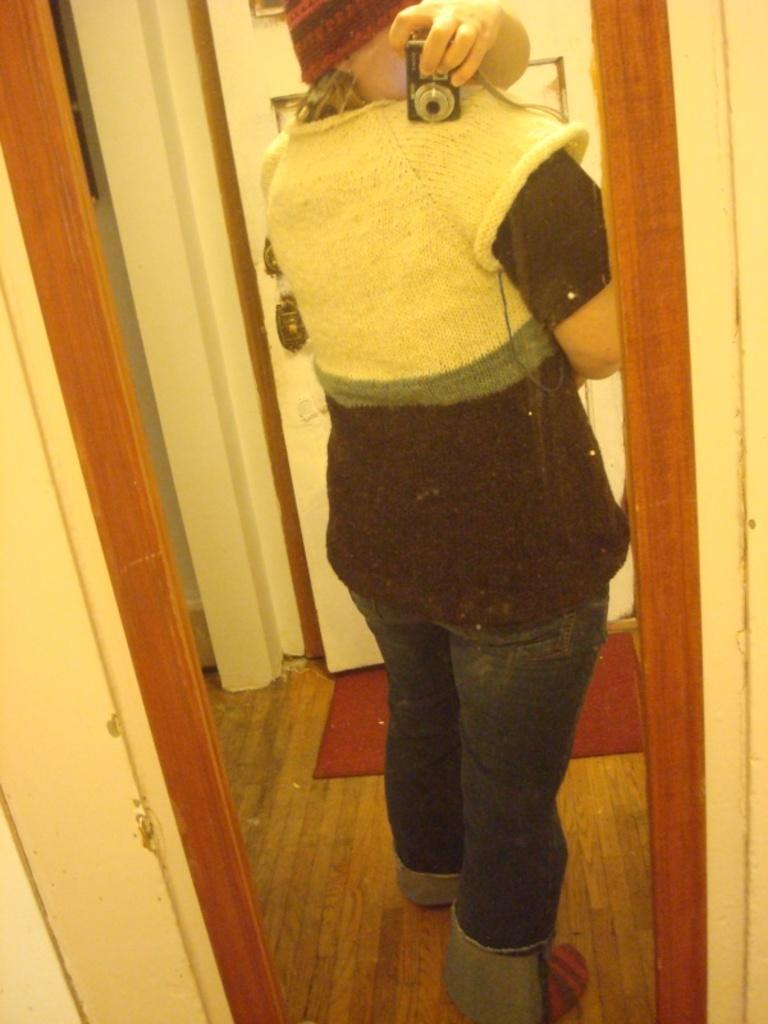How would you summarize this image in a sentence or two? In this image there is a mirror having a reflection of a person standing on the floor having a mat. He is holding camera in his hand. He is wearing a cap. Behind him there is a door to the wall. 